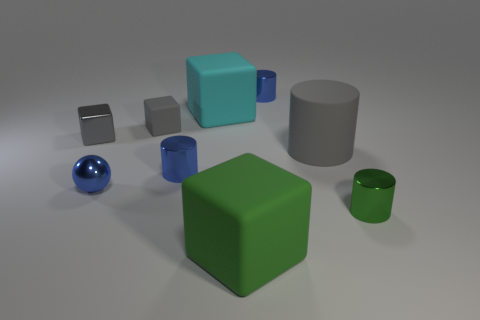What number of other big cylinders have the same material as the big cylinder?
Make the answer very short. 0. There is a gray rubber block; does it have the same size as the cube that is behind the small matte thing?
Keep it short and to the point. No. What color is the tiny cylinder that is both in front of the tiny gray rubber thing and left of the big gray thing?
Provide a succinct answer. Blue. There is a blue object that is right of the green rubber object; is there a big cyan cube behind it?
Offer a terse response. No. Are there an equal number of gray cylinders behind the tiny metallic block and large purple matte blocks?
Give a very brief answer. Yes. There is a big thing in front of the green thing that is right of the big gray object; what number of cyan cubes are on the left side of it?
Make the answer very short. 1. Is there a gray matte cylinder that has the same size as the gray shiny object?
Keep it short and to the point. No. Is the number of large green rubber objects that are to the left of the cyan thing less than the number of cyan shiny cylinders?
Ensure brevity in your answer.  No. What is the material of the block left of the gray thing behind the tiny gray thing that is in front of the tiny gray rubber block?
Make the answer very short. Metal. Are there more blue shiny cylinders behind the gray rubber cube than cyan matte cubes on the right side of the large cylinder?
Your response must be concise. Yes. 